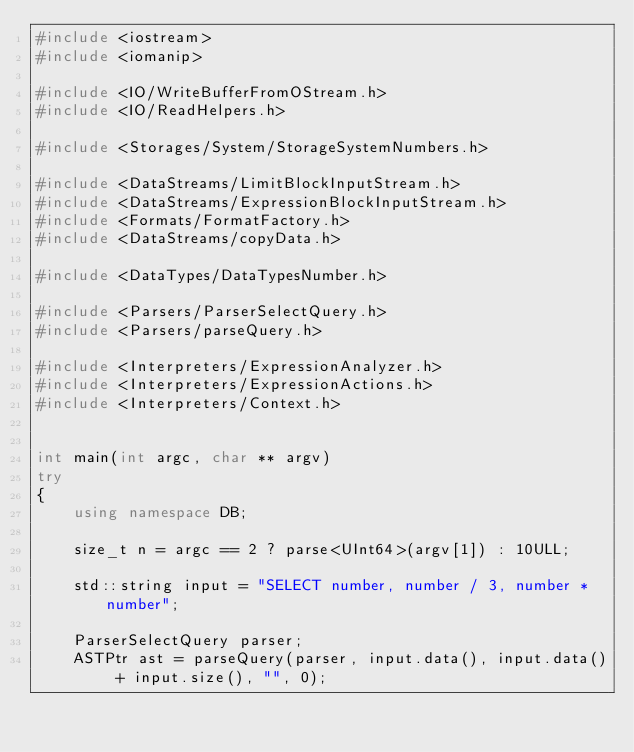Convert code to text. <code><loc_0><loc_0><loc_500><loc_500><_C++_>#include <iostream>
#include <iomanip>

#include <IO/WriteBufferFromOStream.h>
#include <IO/ReadHelpers.h>

#include <Storages/System/StorageSystemNumbers.h>

#include <DataStreams/LimitBlockInputStream.h>
#include <DataStreams/ExpressionBlockInputStream.h>
#include <Formats/FormatFactory.h>
#include <DataStreams/copyData.h>

#include <DataTypes/DataTypesNumber.h>

#include <Parsers/ParserSelectQuery.h>
#include <Parsers/parseQuery.h>

#include <Interpreters/ExpressionAnalyzer.h>
#include <Interpreters/ExpressionActions.h>
#include <Interpreters/Context.h>


int main(int argc, char ** argv)
try
{
    using namespace DB;

    size_t n = argc == 2 ? parse<UInt64>(argv[1]) : 10ULL;

    std::string input = "SELECT number, number / 3, number * number";

    ParserSelectQuery parser;
    ASTPtr ast = parseQuery(parser, input.data(), input.data() + input.size(), "", 0);
</code> 